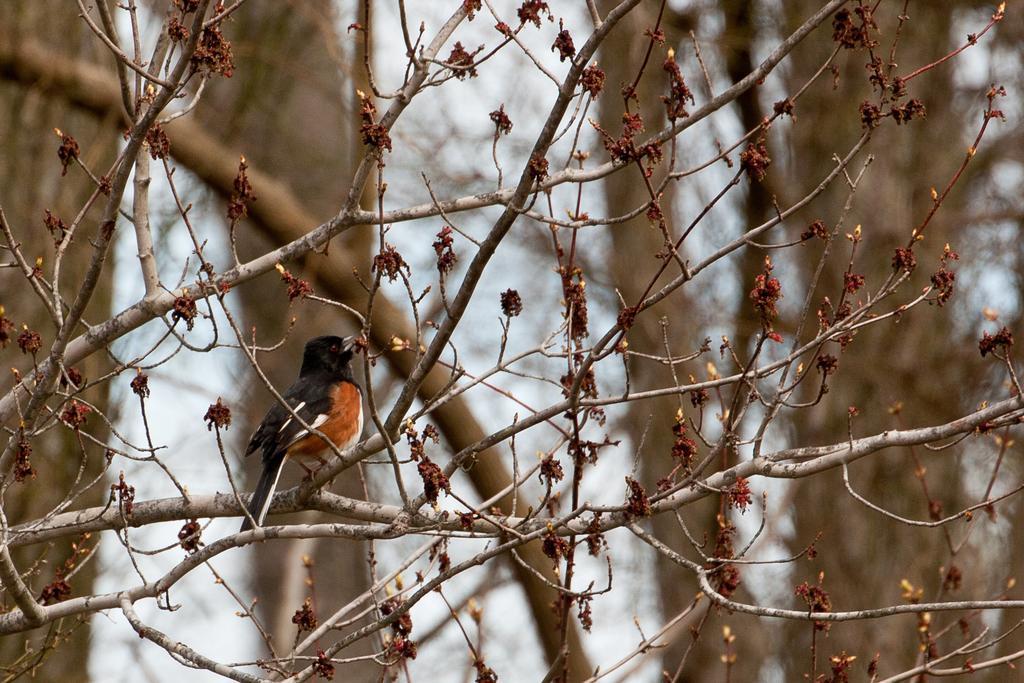Please provide a concise description of this image. This image consists of a bird in brown and black color is sitting on a stem. There are many trees in this image. 